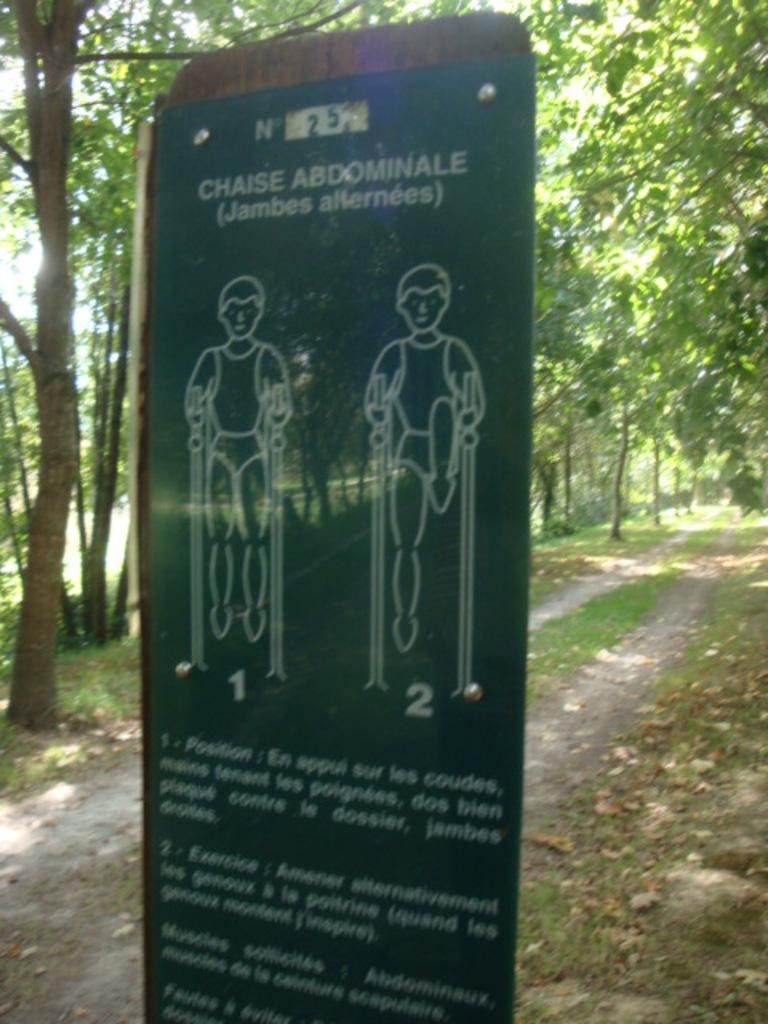What is the main object in the picture? There is a board in the picture. What is on the board? There is writing on the board. What can be seen on the walkway? There is grass on the walkway. What is visible in the background of the picture? There are trees in the background. How would you describe the sky in the picture? The sky is clear in the picture. What type of pet can be seen playing with the attraction in the image? There is no pet or attraction present in the image. 